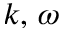Convert formula to latex. <formula><loc_0><loc_0><loc_500><loc_500>k , \, \omega</formula> 